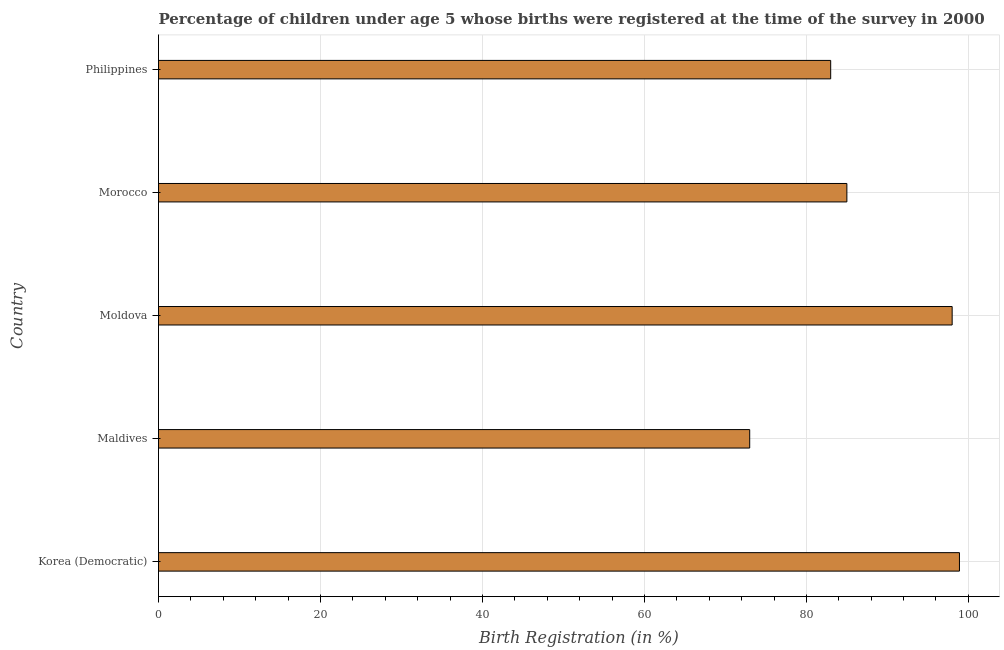Does the graph contain grids?
Provide a short and direct response. Yes. What is the title of the graph?
Give a very brief answer. Percentage of children under age 5 whose births were registered at the time of the survey in 2000. What is the label or title of the X-axis?
Keep it short and to the point. Birth Registration (in %). What is the birth registration in Moldova?
Keep it short and to the point. 98. Across all countries, what is the maximum birth registration?
Give a very brief answer. 98.9. Across all countries, what is the minimum birth registration?
Ensure brevity in your answer.  73. In which country was the birth registration maximum?
Provide a short and direct response. Korea (Democratic). In which country was the birth registration minimum?
Provide a short and direct response. Maldives. What is the sum of the birth registration?
Ensure brevity in your answer.  437.9. What is the average birth registration per country?
Your answer should be compact. 87.58. In how many countries, is the birth registration greater than 16 %?
Offer a very short reply. 5. What is the ratio of the birth registration in Moldova to that in Morocco?
Give a very brief answer. 1.15. What is the difference between the highest and the second highest birth registration?
Provide a succinct answer. 0.9. Is the sum of the birth registration in Maldives and Moldova greater than the maximum birth registration across all countries?
Provide a succinct answer. Yes. What is the difference between the highest and the lowest birth registration?
Your answer should be very brief. 25.9. How many bars are there?
Keep it short and to the point. 5. How many countries are there in the graph?
Offer a very short reply. 5. Are the values on the major ticks of X-axis written in scientific E-notation?
Provide a short and direct response. No. What is the Birth Registration (in %) in Korea (Democratic)?
Offer a very short reply. 98.9. What is the Birth Registration (in %) in Moldova?
Ensure brevity in your answer.  98. What is the Birth Registration (in %) of Philippines?
Your answer should be very brief. 83. What is the difference between the Birth Registration (in %) in Korea (Democratic) and Maldives?
Make the answer very short. 25.9. What is the difference between the Birth Registration (in %) in Maldives and Moldova?
Provide a short and direct response. -25. What is the difference between the Birth Registration (in %) in Moldova and Morocco?
Provide a short and direct response. 13. What is the difference between the Birth Registration (in %) in Moldova and Philippines?
Keep it short and to the point. 15. What is the ratio of the Birth Registration (in %) in Korea (Democratic) to that in Maldives?
Your response must be concise. 1.35. What is the ratio of the Birth Registration (in %) in Korea (Democratic) to that in Morocco?
Your response must be concise. 1.16. What is the ratio of the Birth Registration (in %) in Korea (Democratic) to that in Philippines?
Make the answer very short. 1.19. What is the ratio of the Birth Registration (in %) in Maldives to that in Moldova?
Make the answer very short. 0.74. What is the ratio of the Birth Registration (in %) in Maldives to that in Morocco?
Keep it short and to the point. 0.86. What is the ratio of the Birth Registration (in %) in Moldova to that in Morocco?
Your answer should be very brief. 1.15. What is the ratio of the Birth Registration (in %) in Moldova to that in Philippines?
Your response must be concise. 1.18. What is the ratio of the Birth Registration (in %) in Morocco to that in Philippines?
Your answer should be compact. 1.02. 